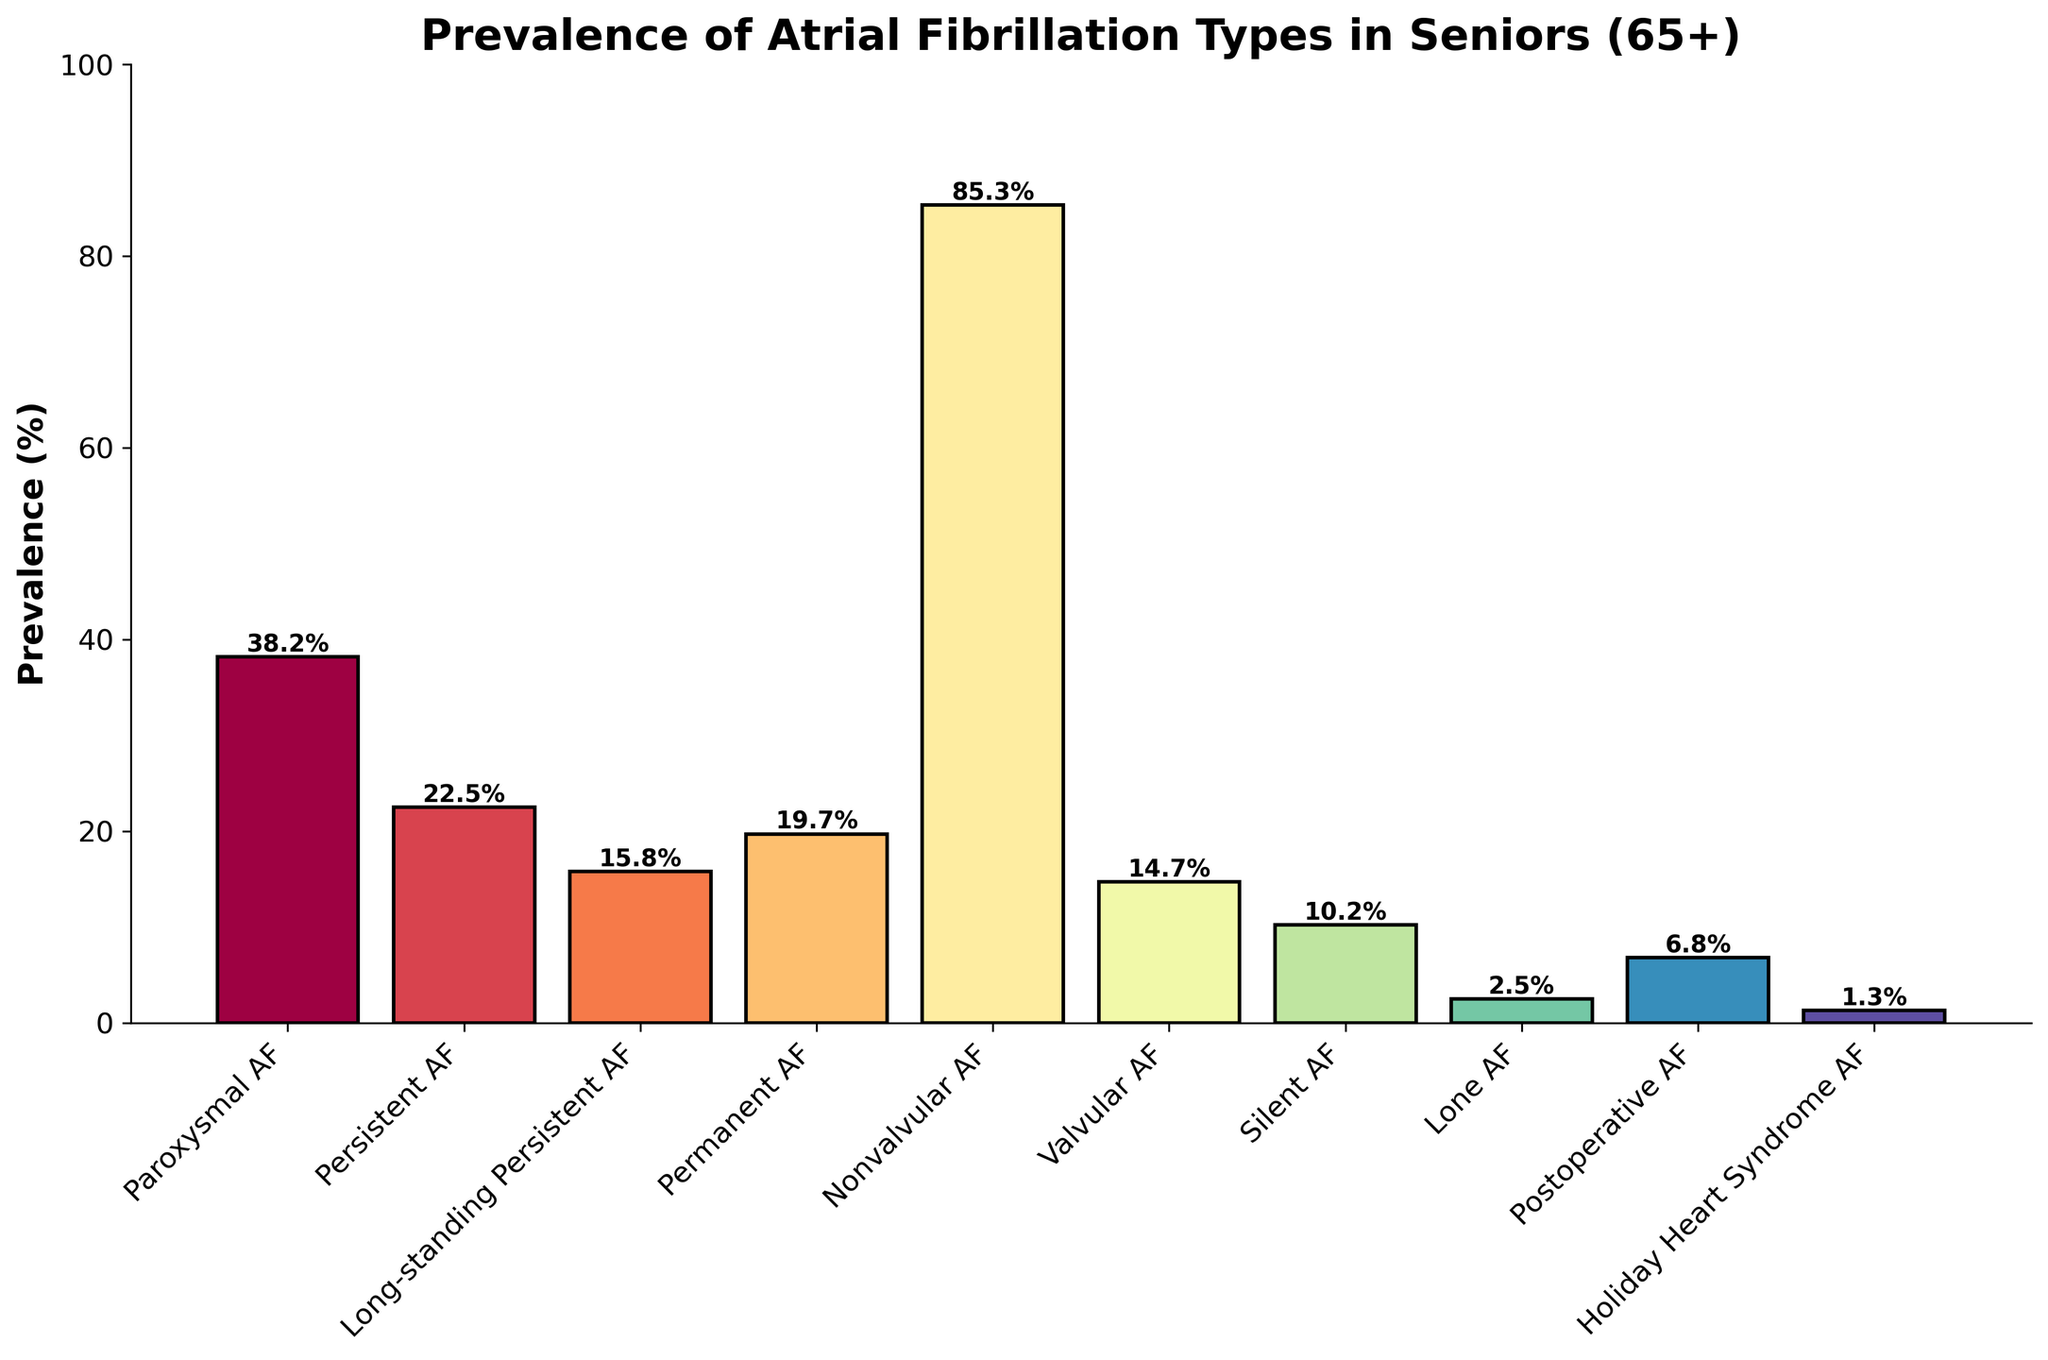What's the most prevalent type of atrial fibrillation among seniors aged 65+ in the US? First, look at the bar chart and identify the bar with the highest height. The label for this bar will indicate the most prevalent type. The highest bar corresponds to "Nonvalvular AF."
Answer: Nonvalvular AF What is the least prevalent type of atrial fibrillation among seniors aged 65+ in the US? First, find the bar with the lowest height on the chart. The label for this bar shows the least prevalent type. The smallest bar corresponds to "Holiday Heart Syndrome AF."
Answer: Holiday Heart Syndrome AF How much more prevalent is Nonvalvular AF compared to Valvular AF? Identify the prevalence percentages for Nonvalvular AF and Valvular AF from the bars. Nonvalvular AF is 85.3%, and Valvular AF is 14.7%. Subtract the prevalence of Valvular AF from that of Nonvalvular AF, i.e., 85.3% - 14.7%.
Answer: 70.6% Which two types of atrial fibrillation have the closest prevalence percentages? Compare the heights of the bars to find the two that are closest in height. Persistent AF is 22.5% and Permanent AF is 19.7%. The difference between them is 2.8, which is smaller than the differences between other pairs.
Answer: Persistent AF and Permanent AF What's the total prevalence percentage for Paroxysmal, Persistent, and Long-standing Persistent AF combined? Find the prevalence percentages for these types: Paroxysmal AF (38.2%), Persistent AF (22.5%), and Long-standing Persistent AF (15.8%). Sum these values: 38.2% + 22.5% + 15.8% = 76.5%.
Answer: 76.5% Which type of atrial fibrillation is represented by a bar that is about half the height of Nonvalvular AF's bar? First, note the prevalence for Nonvalvular AF is 85.3%. Half of this is approximately 42.65%. Look for a bar close to this height. Paroxysmal AF at 38.2% is closest to half.
Answer: Paroxysmal AF Is the prevalence of Lone AF greater than that of Silent AF? Compare the heights or values directly from the chart: Lone AF has a prevalence of 2.5%, and Silent AF has 10.2%. 2.5% is less than 10.2%.
Answer: No What’s the combined prevalence percentage for Silent AF, Lone AF, and Postoperative AF? Find the prevalence percentages for these types: Silent AF (10.2%), Lone AF (2.5%), and Postoperative AF (6.8%). Sum these values: 10.2% + 2.5% + 6.8% = 19.5%.
Answer: 19.5% Which atrial fibrillation types have a prevalence of more than 20%? Look at the bars and identify those with heights representing values greater than 20%. These are Paroxysmal AF (38.2%) and Persistent AF (22.5%).
Answer: Paroxysmal AF, Persistent AF How many types of atrial fibrillation have a prevalence less than 10%? Count the bars where the height corresponds to prevalence percentages less than 10%. These are Lone AF (2.5%), Postoperative AF (6.8%), and Holiday Heart Syndrome AF (1.3%). There are three types in total.
Answer: Three types 